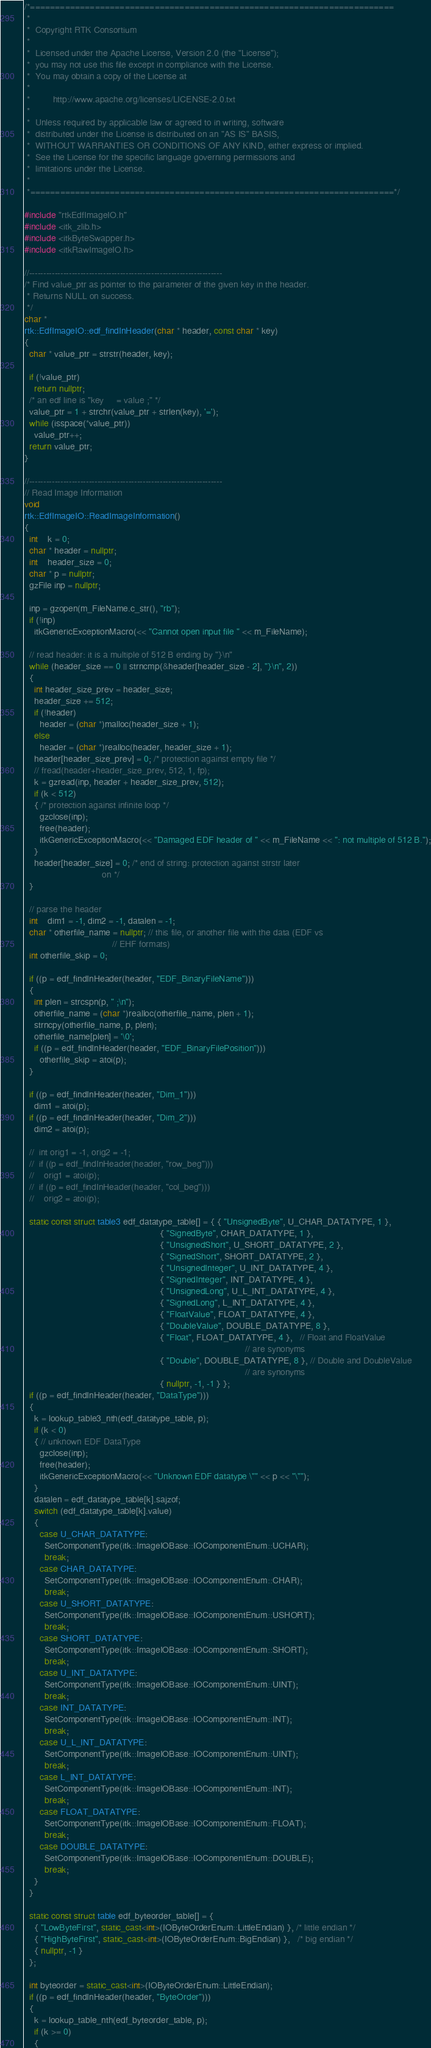Convert code to text. <code><loc_0><loc_0><loc_500><loc_500><_C++_>/*=========================================================================
 *
 *  Copyright RTK Consortium
 *
 *  Licensed under the Apache License, Version 2.0 (the "License");
 *  you may not use this file except in compliance with the License.
 *  You may obtain a copy of the License at
 *
 *         http://www.apache.org/licenses/LICENSE-2.0.txt
 *
 *  Unless required by applicable law or agreed to in writing, software
 *  distributed under the License is distributed on an "AS IS" BASIS,
 *  WITHOUT WARRANTIES OR CONDITIONS OF ANY KIND, either express or implied.
 *  See the License for the specific language governing permissions and
 *  limitations under the License.
 *
 *=========================================================================*/

#include "rtkEdfImageIO.h"
#include <itk_zlib.h>
#include <itkByteSwapper.h>
#include <itkRawImageIO.h>

//--------------------------------------------------------------------
/* Find value_ptr as pointer to the parameter of the given key in the header.
 * Returns NULL on success.
 */
char *
rtk::EdfImageIO::edf_findInHeader(char * header, const char * key)
{
  char * value_ptr = strstr(header, key);

  if (!value_ptr)
    return nullptr;
  /* an edf line is "key     = value ;" */
  value_ptr = 1 + strchr(value_ptr + strlen(key), '=');
  while (isspace(*value_ptr))
    value_ptr++;
  return value_ptr;
}

//--------------------------------------------------------------------
// Read Image Information
void
rtk::EdfImageIO::ReadImageInformation()
{
  int    k = 0;
  char * header = nullptr;
  int    header_size = 0;
  char * p = nullptr;
  gzFile inp = nullptr;

  inp = gzopen(m_FileName.c_str(), "rb");
  if (!inp)
    itkGenericExceptionMacro(<< "Cannot open input file " << m_FileName);

  // read header: it is a multiple of 512 B ending by "}\n"
  while (header_size == 0 || strncmp(&header[header_size - 2], "}\n", 2))
  {
    int header_size_prev = header_size;
    header_size += 512;
    if (!header)
      header = (char *)malloc(header_size + 1);
    else
      header = (char *)realloc(header, header_size + 1);
    header[header_size_prev] = 0; /* protection against empty file */
    // fread(header+header_size_prev, 512, 1, fp);
    k = gzread(inp, header + header_size_prev, 512);
    if (k < 512)
    { /* protection against infinite loop */
      gzclose(inp);
      free(header);
      itkGenericExceptionMacro(<< "Damaged EDF header of " << m_FileName << ": not multiple of 512 B.");
    }
    header[header_size] = 0; /* end of string: protection against strstr later
                               on */
  }

  // parse the header
  int    dim1 = -1, dim2 = -1, datalen = -1;
  char * otherfile_name = nullptr; // this file, or another file with the data (EDF vs
                                   // EHF formats)
  int otherfile_skip = 0;

  if ((p = edf_findInHeader(header, "EDF_BinaryFileName")))
  {
    int plen = strcspn(p, " ;\n");
    otherfile_name = (char *)realloc(otherfile_name, plen + 1);
    strncpy(otherfile_name, p, plen);
    otherfile_name[plen] = '\0';
    if ((p = edf_findInHeader(header, "EDF_BinaryFilePosition")))
      otherfile_skip = atoi(p);
  }

  if ((p = edf_findInHeader(header, "Dim_1")))
    dim1 = atoi(p);
  if ((p = edf_findInHeader(header, "Dim_2")))
    dim2 = atoi(p);

  //  int orig1 = -1, orig2 = -1;
  //  if ((p = edf_findInHeader(header, "row_beg")))
  //    orig1 = atoi(p);
  //  if ((p = edf_findInHeader(header, "col_beg")))
  //    orig2 = atoi(p);

  static const struct table3 edf_datatype_table[] = { { "UnsignedByte", U_CHAR_DATATYPE, 1 },
                                                      { "SignedByte", CHAR_DATATYPE, 1 },
                                                      { "UnsignedShort", U_SHORT_DATATYPE, 2 },
                                                      { "SignedShort", SHORT_DATATYPE, 2 },
                                                      { "UnsignedInteger", U_INT_DATATYPE, 4 },
                                                      { "SignedInteger", INT_DATATYPE, 4 },
                                                      { "UnsignedLong", U_L_INT_DATATYPE, 4 },
                                                      { "SignedLong", L_INT_DATATYPE, 4 },
                                                      { "FloatValue", FLOAT_DATATYPE, 4 },
                                                      { "DoubleValue", DOUBLE_DATATYPE, 8 },
                                                      { "Float", FLOAT_DATATYPE, 4 },   // Float and FloatValue
                                                                                        // are synonyms
                                                      { "Double", DOUBLE_DATATYPE, 8 }, // Double and DoubleValue
                                                                                        // are synonyms
                                                      { nullptr, -1, -1 } };
  if ((p = edf_findInHeader(header, "DataType")))
  {
    k = lookup_table3_nth(edf_datatype_table, p);
    if (k < 0)
    { // unknown EDF DataType
      gzclose(inp);
      free(header);
      itkGenericExceptionMacro(<< "Unknown EDF datatype \"" << p << "\"");
    }
    datalen = edf_datatype_table[k].sajzof;
    switch (edf_datatype_table[k].value)
    {
      case U_CHAR_DATATYPE:
        SetComponentType(itk::ImageIOBase::IOComponentEnum::UCHAR);
        break;
      case CHAR_DATATYPE:
        SetComponentType(itk::ImageIOBase::IOComponentEnum::CHAR);
        break;
      case U_SHORT_DATATYPE:
        SetComponentType(itk::ImageIOBase::IOComponentEnum::USHORT);
        break;
      case SHORT_DATATYPE:
        SetComponentType(itk::ImageIOBase::IOComponentEnum::SHORT);
        break;
      case U_INT_DATATYPE:
        SetComponentType(itk::ImageIOBase::IOComponentEnum::UINT);
        break;
      case INT_DATATYPE:
        SetComponentType(itk::ImageIOBase::IOComponentEnum::INT);
        break;
      case U_L_INT_DATATYPE:
        SetComponentType(itk::ImageIOBase::IOComponentEnum::UINT);
        break;
      case L_INT_DATATYPE:
        SetComponentType(itk::ImageIOBase::IOComponentEnum::INT);
        break;
      case FLOAT_DATATYPE:
        SetComponentType(itk::ImageIOBase::IOComponentEnum::FLOAT);
        break;
      case DOUBLE_DATATYPE:
        SetComponentType(itk::ImageIOBase::IOComponentEnum::DOUBLE);
        break;
    }
  }

  static const struct table edf_byteorder_table[] = {
    { "LowByteFirst", static_cast<int>(IOByteOrderEnum::LittleEndian) }, /* little endian */
    { "HighByteFirst", static_cast<int>(IOByteOrderEnum::BigEndian) },   /* big endian */
    { nullptr, -1 }
  };

  int byteorder = static_cast<int>(IOByteOrderEnum::LittleEndian);
  if ((p = edf_findInHeader(header, "ByteOrder")))
  {
    k = lookup_table_nth(edf_byteorder_table, p);
    if (k >= 0)
    {
</code> 